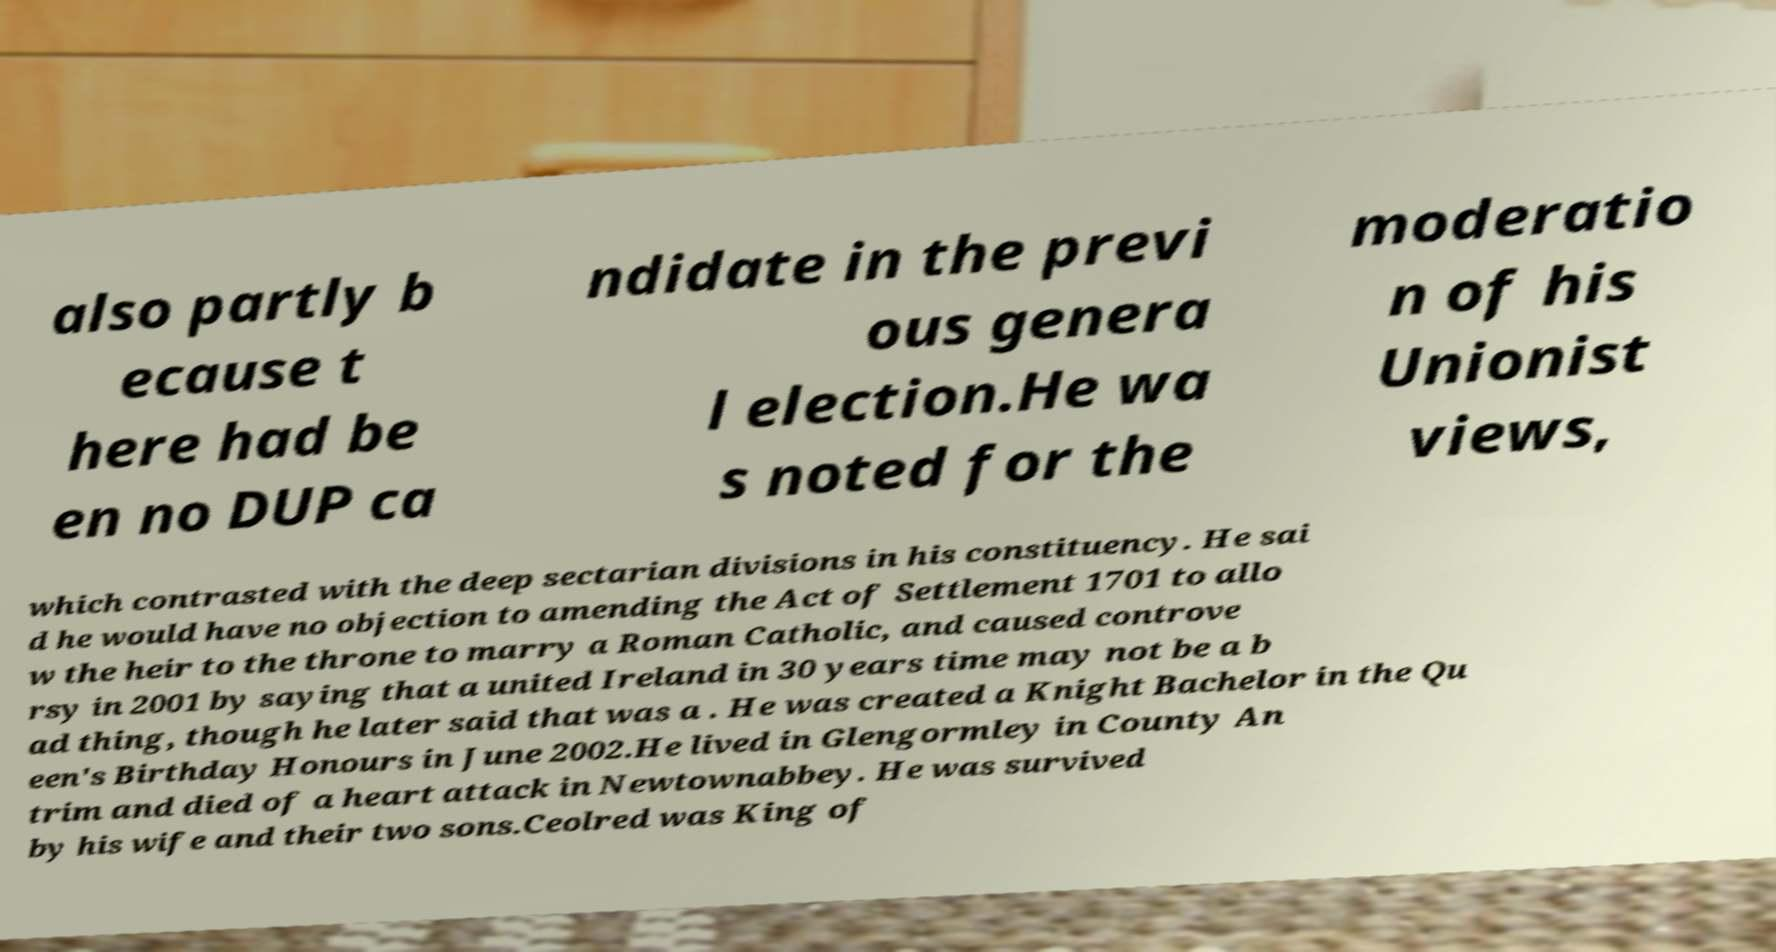Can you accurately transcribe the text from the provided image for me? also partly b ecause t here had be en no DUP ca ndidate in the previ ous genera l election.He wa s noted for the moderatio n of his Unionist views, which contrasted with the deep sectarian divisions in his constituency. He sai d he would have no objection to amending the Act of Settlement 1701 to allo w the heir to the throne to marry a Roman Catholic, and caused controve rsy in 2001 by saying that a united Ireland in 30 years time may not be a b ad thing, though he later said that was a . He was created a Knight Bachelor in the Qu een's Birthday Honours in June 2002.He lived in Glengormley in County An trim and died of a heart attack in Newtownabbey. He was survived by his wife and their two sons.Ceolred was King of 